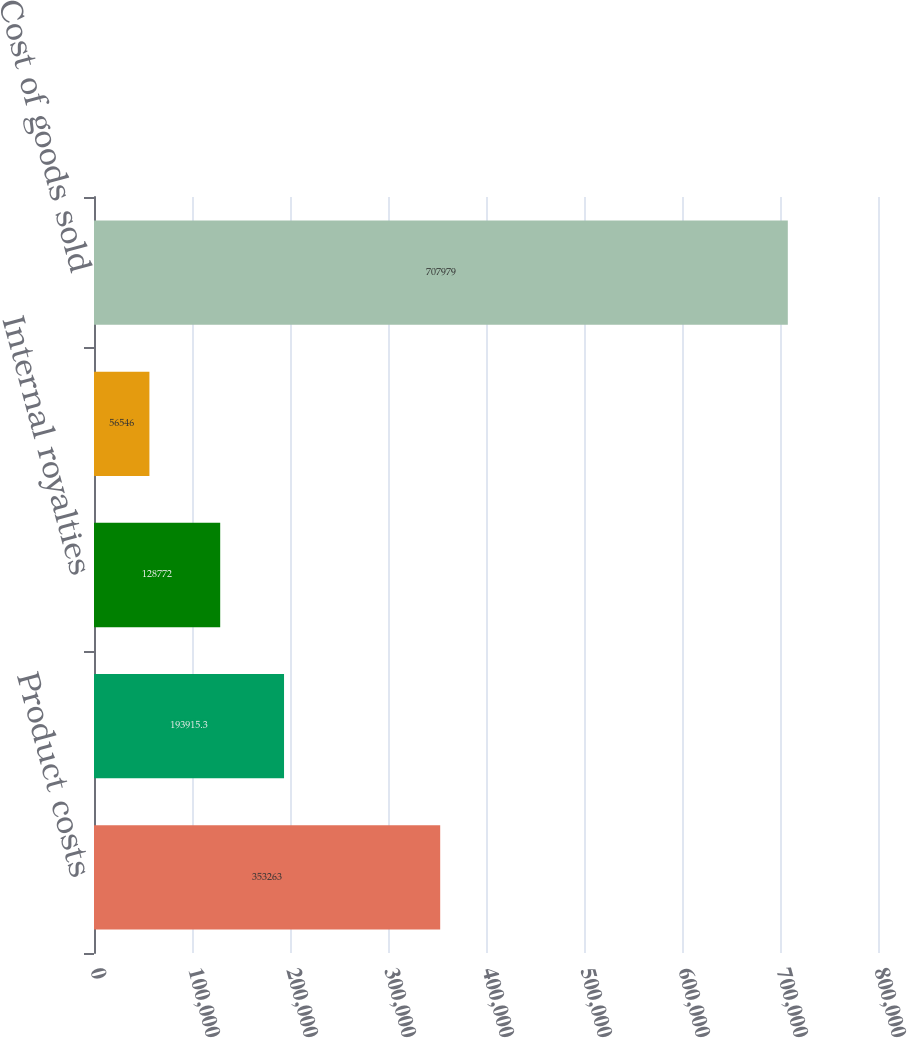Convert chart. <chart><loc_0><loc_0><loc_500><loc_500><bar_chart><fcel>Product costs<fcel>Software development costs and<fcel>Internal royalties<fcel>Licenses<fcel>Cost of goods sold<nl><fcel>353263<fcel>193915<fcel>128772<fcel>56546<fcel>707979<nl></chart> 